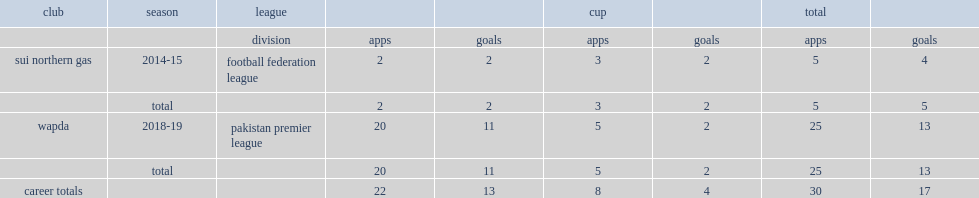In 2014-15, which league did faheem start his career with sui northern gas, making his debut for the club in? Football federation league. 